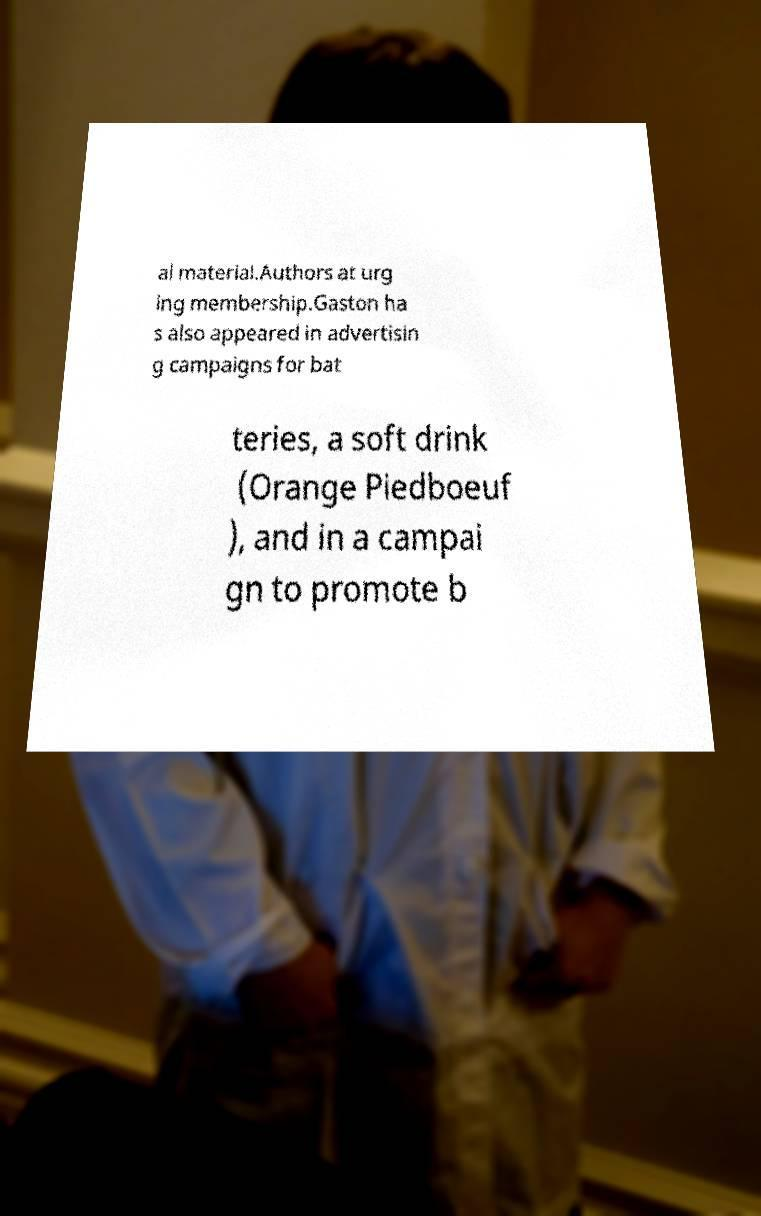Please read and relay the text visible in this image. What does it say? al material.Authors at urg ing membership.Gaston ha s also appeared in advertisin g campaigns for bat teries, a soft drink (Orange Piedboeuf ), and in a campai gn to promote b 